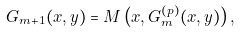Convert formula to latex. <formula><loc_0><loc_0><loc_500><loc_500>G _ { m + 1 } ( x , y ) = M \left ( x , G _ { m } ^ { ( p ) } ( x , y ) \right ) ,</formula> 